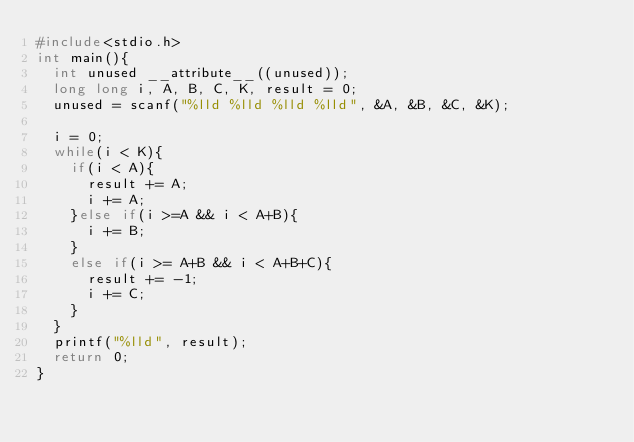Convert code to text. <code><loc_0><loc_0><loc_500><loc_500><_C_>#include<stdio.h>
int main(){
  int unused __attribute__((unused));
  long long i, A, B, C, K, result = 0;
  unused = scanf("%lld %lld %lld %lld", &A, &B, &C, &K);

  i = 0;
  while(i < K){
    if(i < A){
      result += A;
      i += A;
    }else if(i >=A && i < A+B){
      i += B;
    }
    else if(i >= A+B && i < A+B+C){
      result += -1;
      i += C;
    }
  }
  printf("%lld", result);
  return 0;
}
</code> 